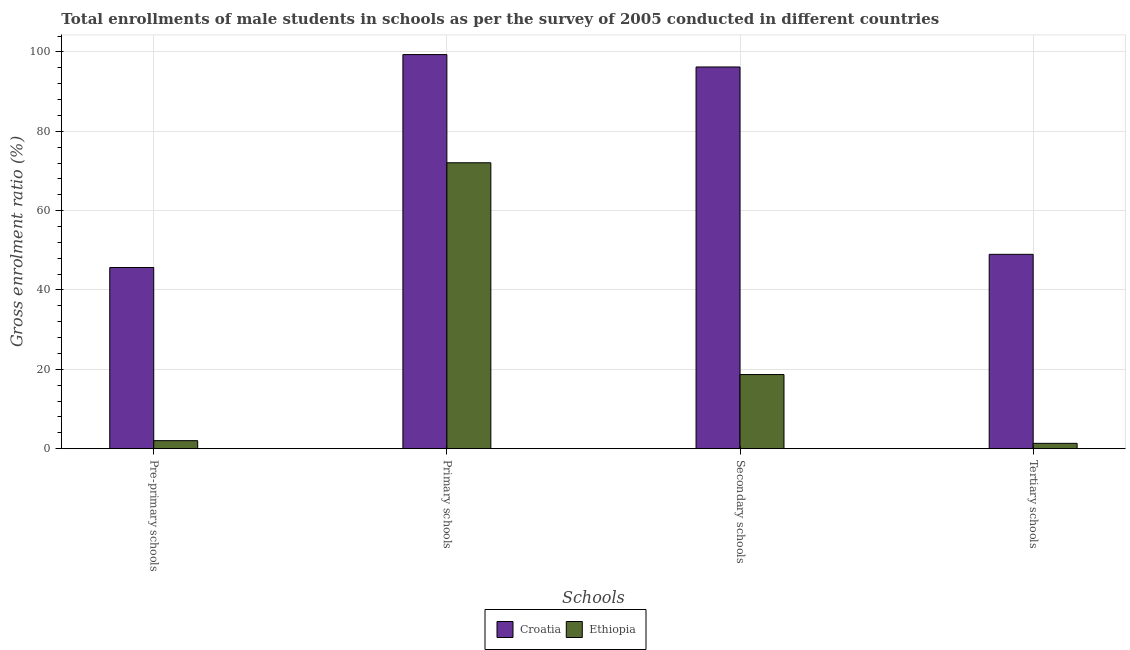How many bars are there on the 3rd tick from the left?
Keep it short and to the point. 2. How many bars are there on the 4th tick from the right?
Give a very brief answer. 2. What is the label of the 2nd group of bars from the left?
Keep it short and to the point. Primary schools. What is the gross enrolment ratio(male) in primary schools in Ethiopia?
Keep it short and to the point. 72.07. Across all countries, what is the maximum gross enrolment ratio(male) in primary schools?
Your answer should be very brief. 99.34. Across all countries, what is the minimum gross enrolment ratio(male) in primary schools?
Offer a terse response. 72.07. In which country was the gross enrolment ratio(male) in pre-primary schools maximum?
Your response must be concise. Croatia. In which country was the gross enrolment ratio(male) in tertiary schools minimum?
Your answer should be compact. Ethiopia. What is the total gross enrolment ratio(male) in tertiary schools in the graph?
Your response must be concise. 50.34. What is the difference between the gross enrolment ratio(male) in pre-primary schools in Croatia and that in Ethiopia?
Your response must be concise. 43.65. What is the difference between the gross enrolment ratio(male) in primary schools in Ethiopia and the gross enrolment ratio(male) in secondary schools in Croatia?
Offer a terse response. -24.15. What is the average gross enrolment ratio(male) in secondary schools per country?
Your answer should be compact. 57.45. What is the difference between the gross enrolment ratio(male) in primary schools and gross enrolment ratio(male) in secondary schools in Croatia?
Your answer should be compact. 3.12. In how many countries, is the gross enrolment ratio(male) in tertiary schools greater than 88 %?
Offer a terse response. 0. What is the ratio of the gross enrolment ratio(male) in tertiary schools in Ethiopia to that in Croatia?
Ensure brevity in your answer.  0.03. Is the difference between the gross enrolment ratio(male) in tertiary schools in Croatia and Ethiopia greater than the difference between the gross enrolment ratio(male) in secondary schools in Croatia and Ethiopia?
Provide a succinct answer. No. What is the difference between the highest and the second highest gross enrolment ratio(male) in primary schools?
Offer a terse response. 27.27. What is the difference between the highest and the lowest gross enrolment ratio(male) in secondary schools?
Make the answer very short. 77.54. Is it the case that in every country, the sum of the gross enrolment ratio(male) in primary schools and gross enrolment ratio(male) in pre-primary schools is greater than the sum of gross enrolment ratio(male) in tertiary schools and gross enrolment ratio(male) in secondary schools?
Offer a very short reply. No. What does the 2nd bar from the left in Pre-primary schools represents?
Offer a terse response. Ethiopia. What does the 2nd bar from the right in Primary schools represents?
Your answer should be very brief. Croatia. How many bars are there?
Keep it short and to the point. 8. Are all the bars in the graph horizontal?
Ensure brevity in your answer.  No. Does the graph contain grids?
Keep it short and to the point. Yes. How are the legend labels stacked?
Ensure brevity in your answer.  Horizontal. What is the title of the graph?
Keep it short and to the point. Total enrollments of male students in schools as per the survey of 2005 conducted in different countries. Does "Nigeria" appear as one of the legend labels in the graph?
Your answer should be very brief. No. What is the label or title of the X-axis?
Your response must be concise. Schools. What is the Gross enrolment ratio (%) in Croatia in Pre-primary schools?
Make the answer very short. 45.67. What is the Gross enrolment ratio (%) in Ethiopia in Pre-primary schools?
Keep it short and to the point. 2.02. What is the Gross enrolment ratio (%) of Croatia in Primary schools?
Your response must be concise. 99.34. What is the Gross enrolment ratio (%) of Ethiopia in Primary schools?
Make the answer very short. 72.07. What is the Gross enrolment ratio (%) of Croatia in Secondary schools?
Offer a terse response. 96.22. What is the Gross enrolment ratio (%) in Ethiopia in Secondary schools?
Make the answer very short. 18.68. What is the Gross enrolment ratio (%) of Croatia in Tertiary schools?
Offer a terse response. 48.99. What is the Gross enrolment ratio (%) of Ethiopia in Tertiary schools?
Ensure brevity in your answer.  1.35. Across all Schools, what is the maximum Gross enrolment ratio (%) of Croatia?
Ensure brevity in your answer.  99.34. Across all Schools, what is the maximum Gross enrolment ratio (%) in Ethiopia?
Give a very brief answer. 72.07. Across all Schools, what is the minimum Gross enrolment ratio (%) in Croatia?
Give a very brief answer. 45.67. Across all Schools, what is the minimum Gross enrolment ratio (%) of Ethiopia?
Offer a very short reply. 1.35. What is the total Gross enrolment ratio (%) in Croatia in the graph?
Keep it short and to the point. 290.22. What is the total Gross enrolment ratio (%) of Ethiopia in the graph?
Offer a very short reply. 94.12. What is the difference between the Gross enrolment ratio (%) in Croatia in Pre-primary schools and that in Primary schools?
Your answer should be compact. -53.68. What is the difference between the Gross enrolment ratio (%) in Ethiopia in Pre-primary schools and that in Primary schools?
Your answer should be very brief. -70.05. What is the difference between the Gross enrolment ratio (%) of Croatia in Pre-primary schools and that in Secondary schools?
Provide a succinct answer. -50.55. What is the difference between the Gross enrolment ratio (%) of Ethiopia in Pre-primary schools and that in Secondary schools?
Your answer should be compact. -16.66. What is the difference between the Gross enrolment ratio (%) in Croatia in Pre-primary schools and that in Tertiary schools?
Keep it short and to the point. -3.32. What is the difference between the Gross enrolment ratio (%) in Ethiopia in Pre-primary schools and that in Tertiary schools?
Your answer should be very brief. 0.67. What is the difference between the Gross enrolment ratio (%) of Croatia in Primary schools and that in Secondary schools?
Your answer should be very brief. 3.12. What is the difference between the Gross enrolment ratio (%) in Ethiopia in Primary schools and that in Secondary schools?
Give a very brief answer. 53.39. What is the difference between the Gross enrolment ratio (%) in Croatia in Primary schools and that in Tertiary schools?
Your answer should be very brief. 50.35. What is the difference between the Gross enrolment ratio (%) in Ethiopia in Primary schools and that in Tertiary schools?
Keep it short and to the point. 70.72. What is the difference between the Gross enrolment ratio (%) in Croatia in Secondary schools and that in Tertiary schools?
Your answer should be very brief. 47.23. What is the difference between the Gross enrolment ratio (%) in Ethiopia in Secondary schools and that in Tertiary schools?
Give a very brief answer. 17.34. What is the difference between the Gross enrolment ratio (%) of Croatia in Pre-primary schools and the Gross enrolment ratio (%) of Ethiopia in Primary schools?
Ensure brevity in your answer.  -26.4. What is the difference between the Gross enrolment ratio (%) in Croatia in Pre-primary schools and the Gross enrolment ratio (%) in Ethiopia in Secondary schools?
Provide a short and direct response. 26.98. What is the difference between the Gross enrolment ratio (%) in Croatia in Pre-primary schools and the Gross enrolment ratio (%) in Ethiopia in Tertiary schools?
Provide a short and direct response. 44.32. What is the difference between the Gross enrolment ratio (%) of Croatia in Primary schools and the Gross enrolment ratio (%) of Ethiopia in Secondary schools?
Make the answer very short. 80.66. What is the difference between the Gross enrolment ratio (%) in Croatia in Primary schools and the Gross enrolment ratio (%) in Ethiopia in Tertiary schools?
Provide a short and direct response. 98. What is the difference between the Gross enrolment ratio (%) of Croatia in Secondary schools and the Gross enrolment ratio (%) of Ethiopia in Tertiary schools?
Keep it short and to the point. 94.87. What is the average Gross enrolment ratio (%) of Croatia per Schools?
Ensure brevity in your answer.  72.56. What is the average Gross enrolment ratio (%) in Ethiopia per Schools?
Your answer should be compact. 23.53. What is the difference between the Gross enrolment ratio (%) in Croatia and Gross enrolment ratio (%) in Ethiopia in Pre-primary schools?
Provide a succinct answer. 43.65. What is the difference between the Gross enrolment ratio (%) in Croatia and Gross enrolment ratio (%) in Ethiopia in Primary schools?
Your response must be concise. 27.27. What is the difference between the Gross enrolment ratio (%) of Croatia and Gross enrolment ratio (%) of Ethiopia in Secondary schools?
Keep it short and to the point. 77.54. What is the difference between the Gross enrolment ratio (%) in Croatia and Gross enrolment ratio (%) in Ethiopia in Tertiary schools?
Your response must be concise. 47.64. What is the ratio of the Gross enrolment ratio (%) in Croatia in Pre-primary schools to that in Primary schools?
Your answer should be compact. 0.46. What is the ratio of the Gross enrolment ratio (%) of Ethiopia in Pre-primary schools to that in Primary schools?
Your response must be concise. 0.03. What is the ratio of the Gross enrolment ratio (%) in Croatia in Pre-primary schools to that in Secondary schools?
Provide a short and direct response. 0.47. What is the ratio of the Gross enrolment ratio (%) of Ethiopia in Pre-primary schools to that in Secondary schools?
Your answer should be compact. 0.11. What is the ratio of the Gross enrolment ratio (%) of Croatia in Pre-primary schools to that in Tertiary schools?
Offer a terse response. 0.93. What is the ratio of the Gross enrolment ratio (%) of Ethiopia in Pre-primary schools to that in Tertiary schools?
Keep it short and to the point. 1.5. What is the ratio of the Gross enrolment ratio (%) in Croatia in Primary schools to that in Secondary schools?
Ensure brevity in your answer.  1.03. What is the ratio of the Gross enrolment ratio (%) in Ethiopia in Primary schools to that in Secondary schools?
Make the answer very short. 3.86. What is the ratio of the Gross enrolment ratio (%) in Croatia in Primary schools to that in Tertiary schools?
Your answer should be compact. 2.03. What is the ratio of the Gross enrolment ratio (%) in Ethiopia in Primary schools to that in Tertiary schools?
Ensure brevity in your answer.  53.49. What is the ratio of the Gross enrolment ratio (%) in Croatia in Secondary schools to that in Tertiary schools?
Your answer should be very brief. 1.96. What is the ratio of the Gross enrolment ratio (%) of Ethiopia in Secondary schools to that in Tertiary schools?
Your answer should be very brief. 13.87. What is the difference between the highest and the second highest Gross enrolment ratio (%) of Croatia?
Your answer should be very brief. 3.12. What is the difference between the highest and the second highest Gross enrolment ratio (%) of Ethiopia?
Keep it short and to the point. 53.39. What is the difference between the highest and the lowest Gross enrolment ratio (%) of Croatia?
Ensure brevity in your answer.  53.68. What is the difference between the highest and the lowest Gross enrolment ratio (%) in Ethiopia?
Your answer should be compact. 70.72. 